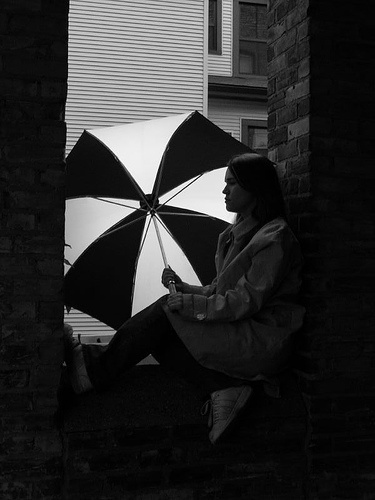Describe the objects in this image and their specific colors. I can see umbrella in black, lightgray, darkgray, and gray tones and people in black, gray, lightgray, and darkgray tones in this image. 